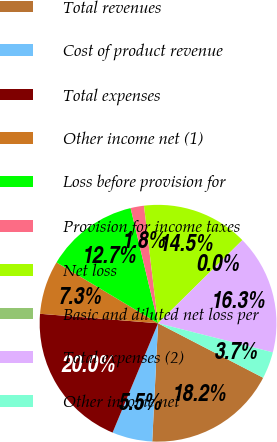Convert chart. <chart><loc_0><loc_0><loc_500><loc_500><pie_chart><fcel>Total revenues<fcel>Cost of product revenue<fcel>Total expenses<fcel>Other income net (1)<fcel>Loss before provision for<fcel>Provision for income taxes<fcel>Net loss<fcel>Basic and diluted net loss per<fcel>Total expenses (2)<fcel>Other income net<nl><fcel>18.17%<fcel>5.49%<fcel>20.0%<fcel>7.32%<fcel>12.68%<fcel>1.83%<fcel>14.51%<fcel>0.0%<fcel>16.34%<fcel>3.66%<nl></chart> 